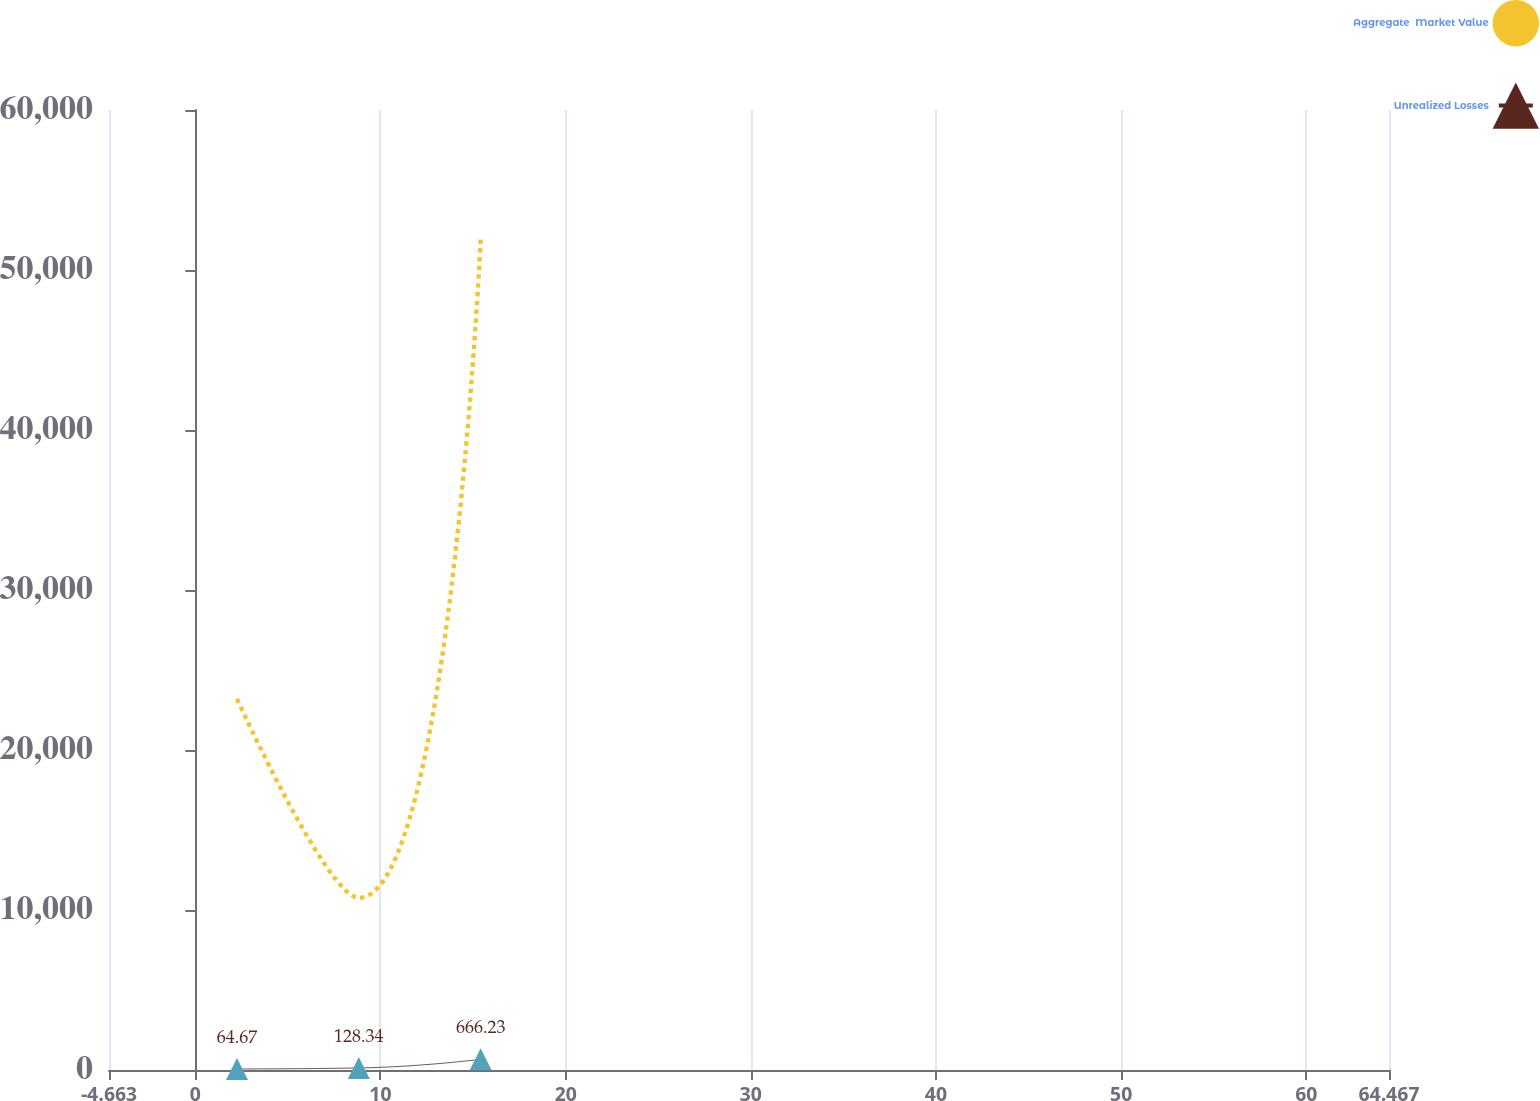Convert chart. <chart><loc_0><loc_0><loc_500><loc_500><line_chart><ecel><fcel>Aggregate  Market Value<fcel>Unrealized Losses<nl><fcel>2.25<fcel>23192.5<fcel>64.67<nl><fcel>8.83<fcel>10752.9<fcel>128.34<nl><fcel>15.41<fcel>51894.2<fcel>666.23<nl><fcel>64.8<fcel>3469.81<fcel>1<nl><fcel>71.38<fcel>76301.1<fcel>602.56<nl></chart> 